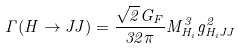Convert formula to latex. <formula><loc_0><loc_0><loc_500><loc_500>\Gamma ( H \rightarrow J J ) = \frac { \sqrt { 2 } G _ { F } } { 3 2 \pi } M _ { H _ { i } } ^ { 3 } g ^ { 2 } _ { H _ { i } J J }</formula> 